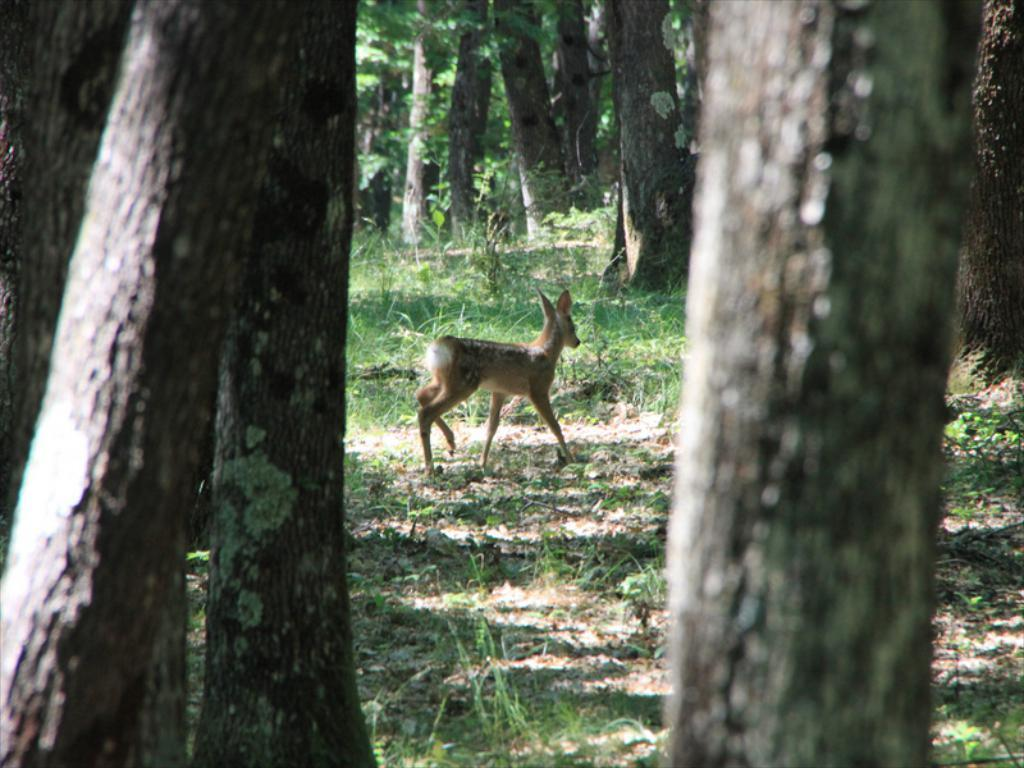What type of vegetation is present in the image? There are trees and grass in the image. What animal can be seen on the ground in the image? There is a deer on the ground in the image. What type of porter is carrying a jar filled with silver in the image? There is no porter, jar, or silver present in the image. 